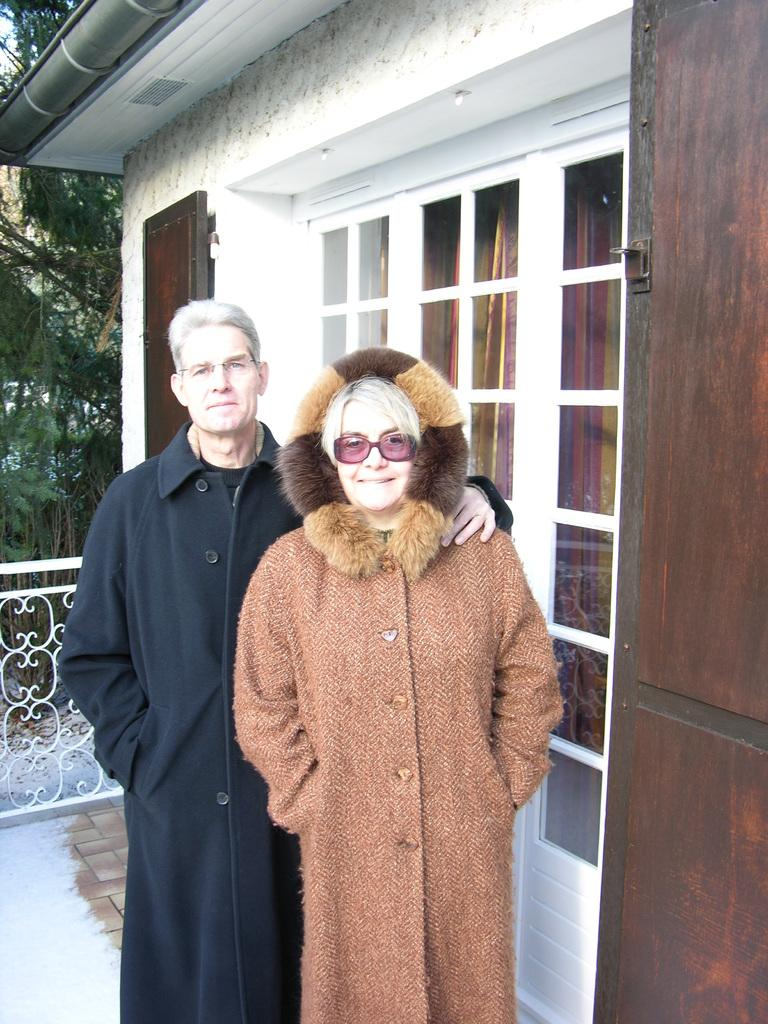Who can be seen in the image? There is a man and a woman standing in the image. What is located on the right side of the image? There is a house on the right side of the image. What can be seen in the background of the image? There are trees in the background of the image. What is in the middle of the image? There is railing in the middle of the image. What type of list is being discussed by the man and woman in the image? There is no list being discussed in the image; the man and woman are simply standing together. What meal are the man and woman preparing in the image? There is no meal preparation or indication of a meal in the image. 